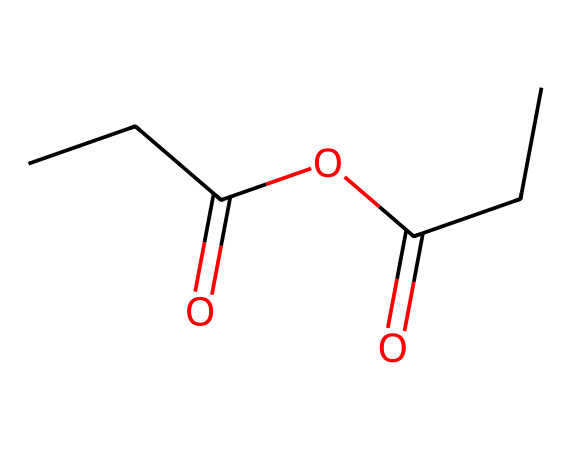How many carbon atoms are present in propionic anhydride? To determine the number of carbon atoms, we can count each 'C' in the SMILES representation. The given SMILES 'CCC(=O)OC(=O)CC' contains five 'C's, indicating there are 5 carbon atoms.
Answer: 5 What is the total number of oxygen atoms in propionic anhydride? In the SMILES representation 'CCC(=O)OC(=O)CC', there are two 'O's, indicated by the two occurrences of 'O', meaning there are 2 oxygen atoms.
Answer: 2 What is the functional group characteristic of acid anhydrides present in this structure? The presence of two carbonyl groups (C=O) in the structure, connected through an oxygen atom, is a defining characteristic of an acid anhydride.
Answer: anhydride What is the molecular formula derived from the structure of propionic anhydride? Analyzing the SMILES 'CCC(=O)OC(=O)CC' shows 5 carbons, 8 hydrogens, and 2 oxygens, which confirms the molecular formula as C5H8O2.
Answer: C5H8O2 What type of reaction can propionic anhydride undergo due to its anhydride nature? Acid anhydrides like propionic anhydride can participate in hydrolysis reactions, where they react with water to form carboxylic acids.
Answer: hydrolysis 